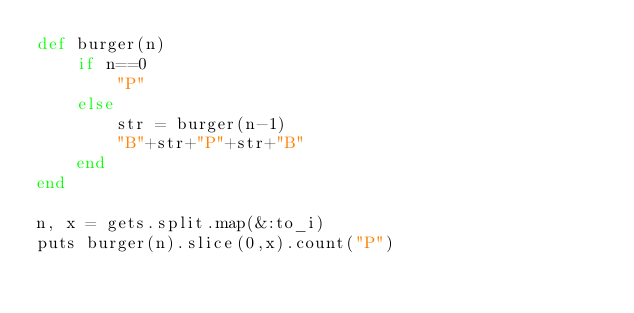<code> <loc_0><loc_0><loc_500><loc_500><_Ruby_>def burger(n)
    if n==0
        "P"
    else
        str = burger(n-1)
        "B"+str+"P"+str+"B"
    end
end

n, x = gets.split.map(&:to_i)
puts burger(n).slice(0,x).count("P") </code> 